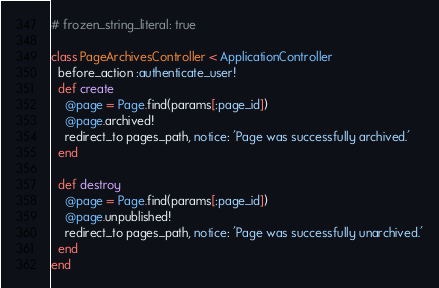Convert code to text. <code><loc_0><loc_0><loc_500><loc_500><_Ruby_># frozen_string_literal: true

class PageArchivesController < ApplicationController
  before_action :authenticate_user!
  def create
    @page = Page.find(params[:page_id])
    @page.archived!
    redirect_to pages_path, notice: 'Page was successfully archived.'
  end

  def destroy
    @page = Page.find(params[:page_id])
    @page.unpublished!
    redirect_to pages_path, notice: 'Page was successfully unarchived.'
  end
end
</code> 